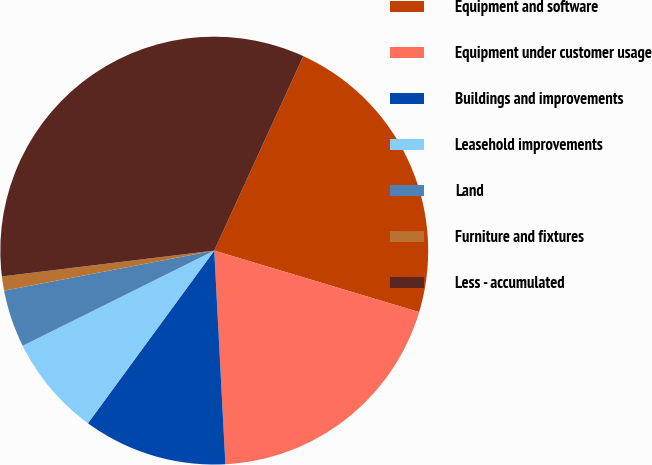<chart> <loc_0><loc_0><loc_500><loc_500><pie_chart><fcel>Equipment and software<fcel>Equipment under customer usage<fcel>Buildings and improvements<fcel>Leasehold improvements<fcel>Land<fcel>Furniture and fixtures<fcel>Less - accumulated<nl><fcel>22.8%<fcel>19.53%<fcel>10.88%<fcel>7.61%<fcel>4.34%<fcel>1.07%<fcel>33.76%<nl></chart> 